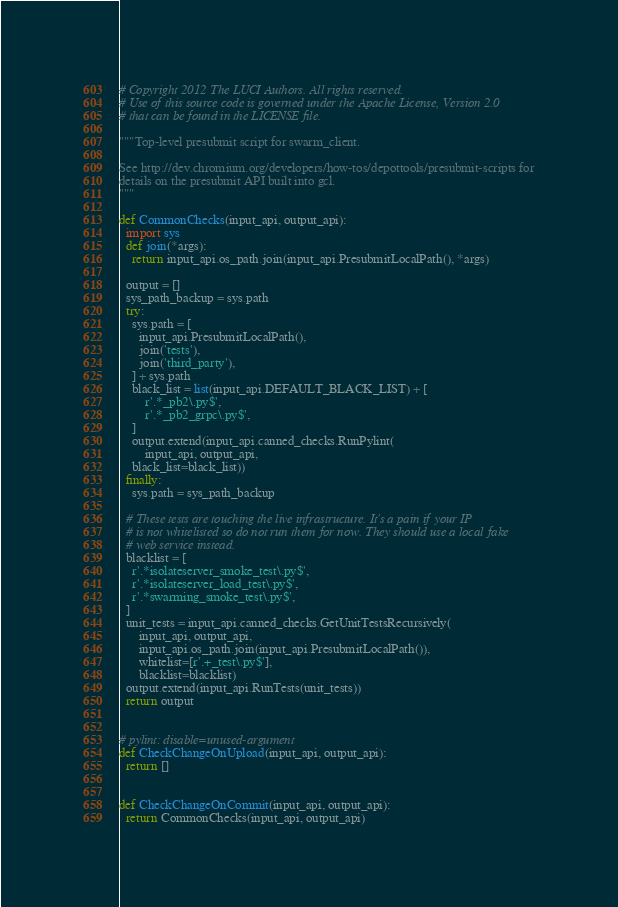<code> <loc_0><loc_0><loc_500><loc_500><_Python_># Copyright 2012 The LUCI Authors. All rights reserved.
# Use of this source code is governed under the Apache License, Version 2.0
# that can be found in the LICENSE file.

"""Top-level presubmit script for swarm_client.

See http://dev.chromium.org/developers/how-tos/depottools/presubmit-scripts for
details on the presubmit API built into gcl.
"""

def CommonChecks(input_api, output_api):
  import sys
  def join(*args):
    return input_api.os_path.join(input_api.PresubmitLocalPath(), *args)

  output = []
  sys_path_backup = sys.path
  try:
    sys.path = [
      input_api.PresubmitLocalPath(),
      join('tests'),
      join('third_party'),
    ] + sys.path
    black_list = list(input_api.DEFAULT_BLACK_LIST) + [
        r'.*_pb2\.py$',
        r'.*_pb2_grpc\.py$',
    ]
    output.extend(input_api.canned_checks.RunPylint(
        input_api, output_api,
    black_list=black_list))
  finally:
    sys.path = sys_path_backup

  # These tests are touching the live infrastructure. It's a pain if your IP
  # is not whitelisted so do not run them for now. They should use a local fake
  # web service instead.
  blacklist = [
    r'.*isolateserver_smoke_test\.py$',
    r'.*isolateserver_load_test\.py$',
    r'.*swarming_smoke_test\.py$',
  ]
  unit_tests = input_api.canned_checks.GetUnitTestsRecursively(
      input_api, output_api,
      input_api.os_path.join(input_api.PresubmitLocalPath()),
      whitelist=[r'.+_test\.py$'],
      blacklist=blacklist)
  output.extend(input_api.RunTests(unit_tests))
  return output


# pylint: disable=unused-argument
def CheckChangeOnUpload(input_api, output_api):
  return []


def CheckChangeOnCommit(input_api, output_api):
  return CommonChecks(input_api, output_api)
</code> 